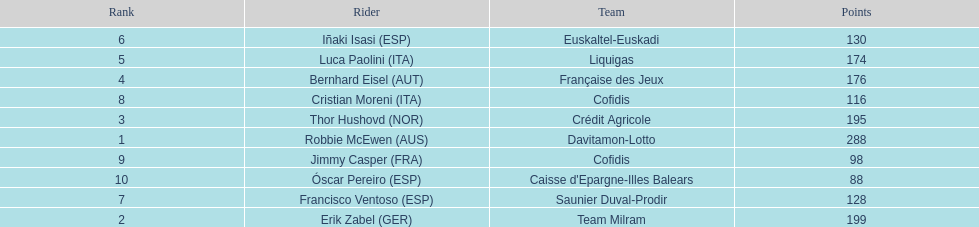How many more points did erik zabel score than franciso ventoso? 71. 